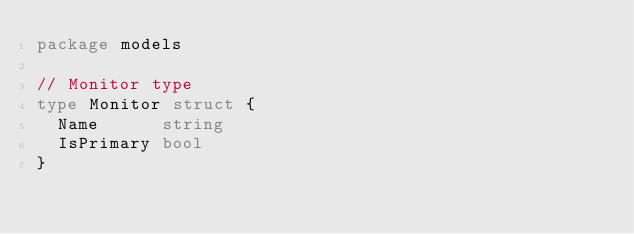<code> <loc_0><loc_0><loc_500><loc_500><_Go_>package models

// Monitor type
type Monitor struct {
	Name      string
	IsPrimary bool
}
</code> 